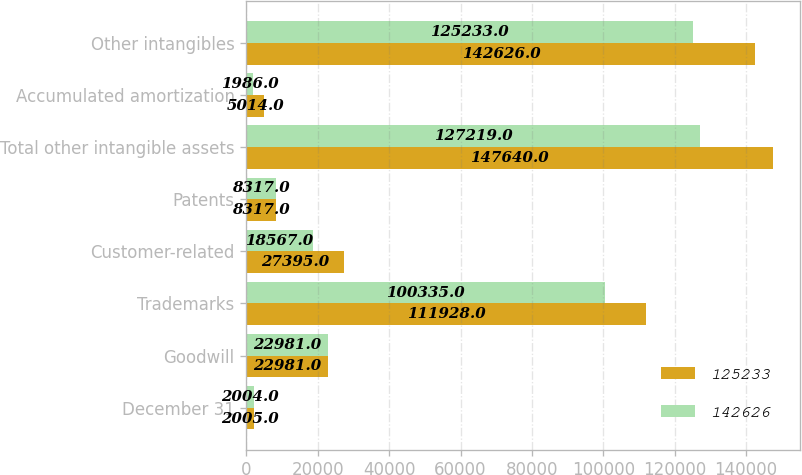Convert chart. <chart><loc_0><loc_0><loc_500><loc_500><stacked_bar_chart><ecel><fcel>December 31<fcel>Goodwill<fcel>Trademarks<fcel>Customer-related<fcel>Patents<fcel>Total other intangible assets<fcel>Accumulated amortization<fcel>Other intangibles<nl><fcel>125233<fcel>2005<fcel>22981<fcel>111928<fcel>27395<fcel>8317<fcel>147640<fcel>5014<fcel>142626<nl><fcel>142626<fcel>2004<fcel>22981<fcel>100335<fcel>18567<fcel>8317<fcel>127219<fcel>1986<fcel>125233<nl></chart> 